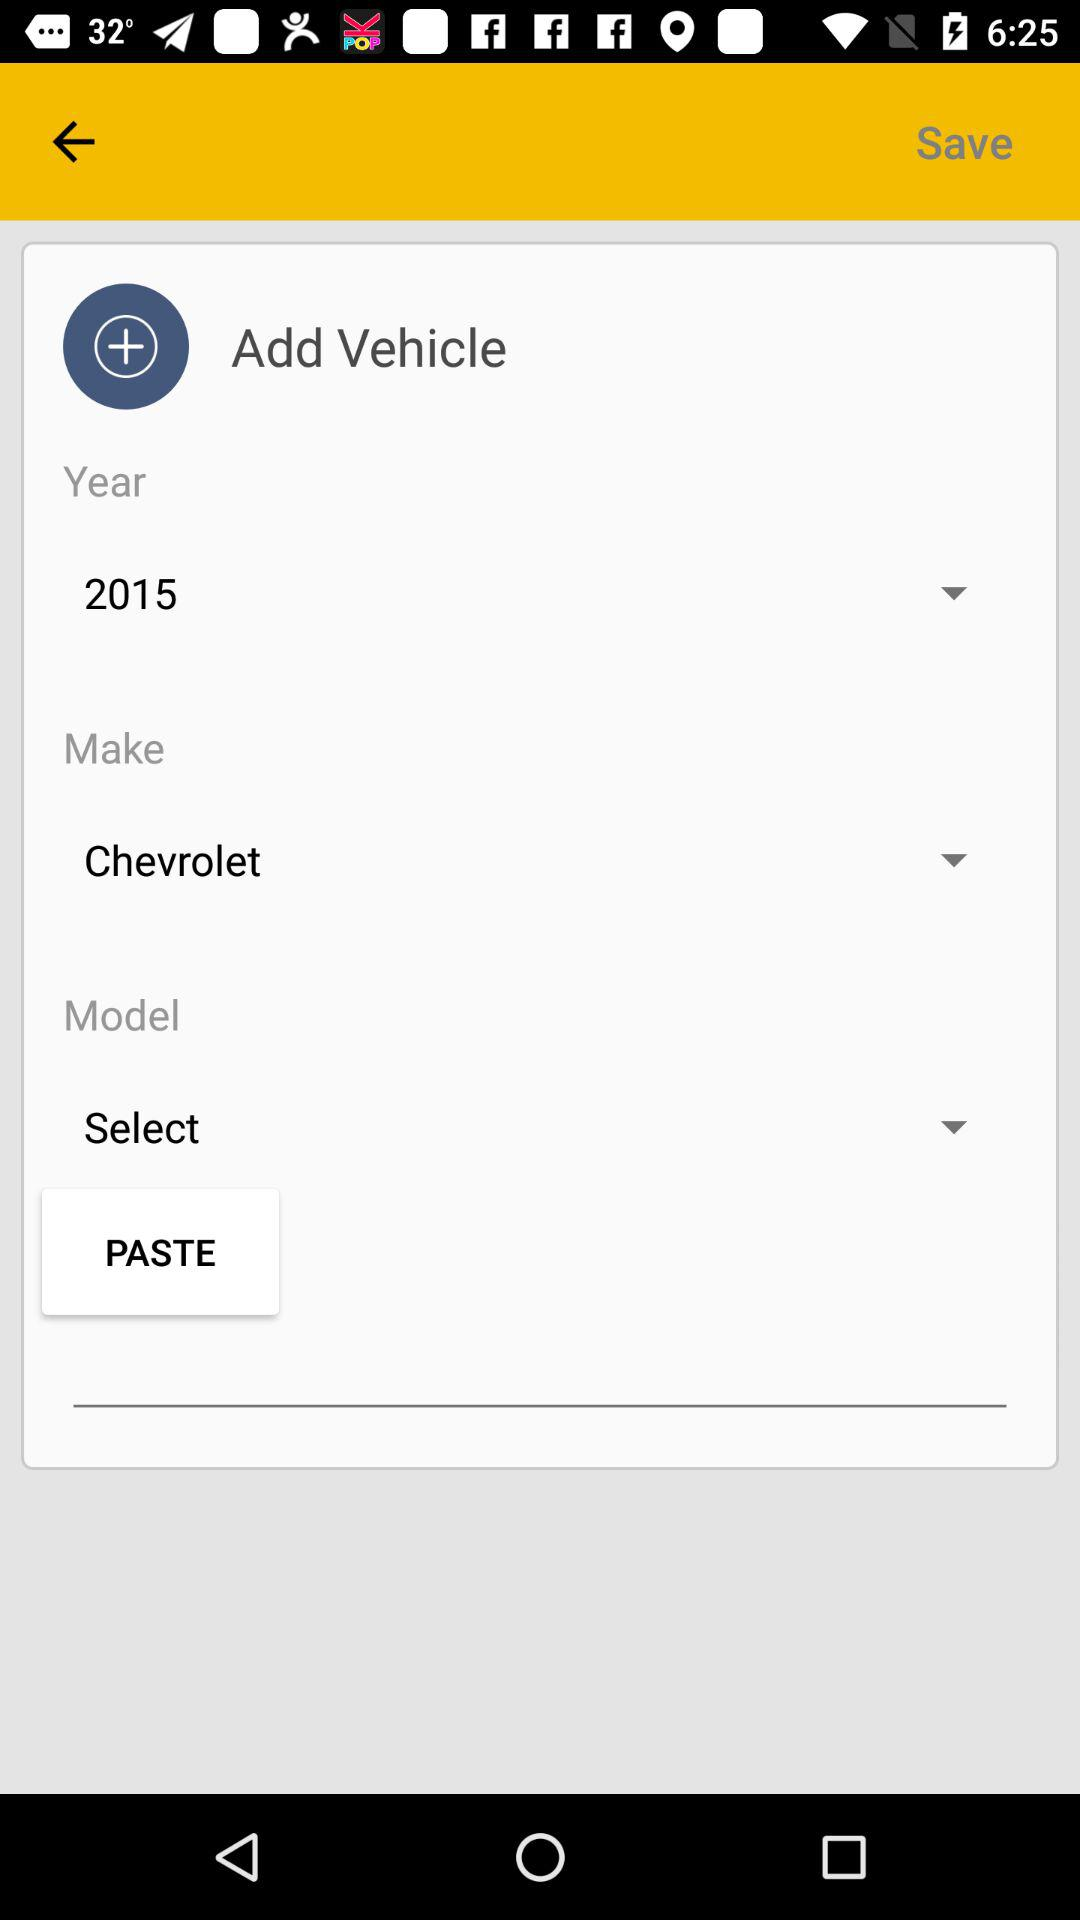What is the selected year for the vehicle? The selected year is 2015. 